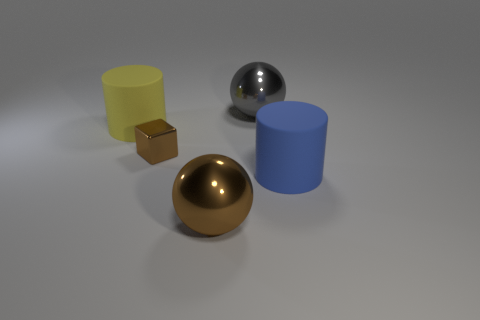Add 4 green rubber cubes. How many objects exist? 9 Subtract all cylinders. How many objects are left? 3 Add 4 small brown cubes. How many small brown cubes are left? 5 Add 4 tiny yellow rubber cubes. How many tiny yellow rubber cubes exist? 4 Subtract 0 red cylinders. How many objects are left? 5 Subtract all large blue objects. Subtract all big matte objects. How many objects are left? 2 